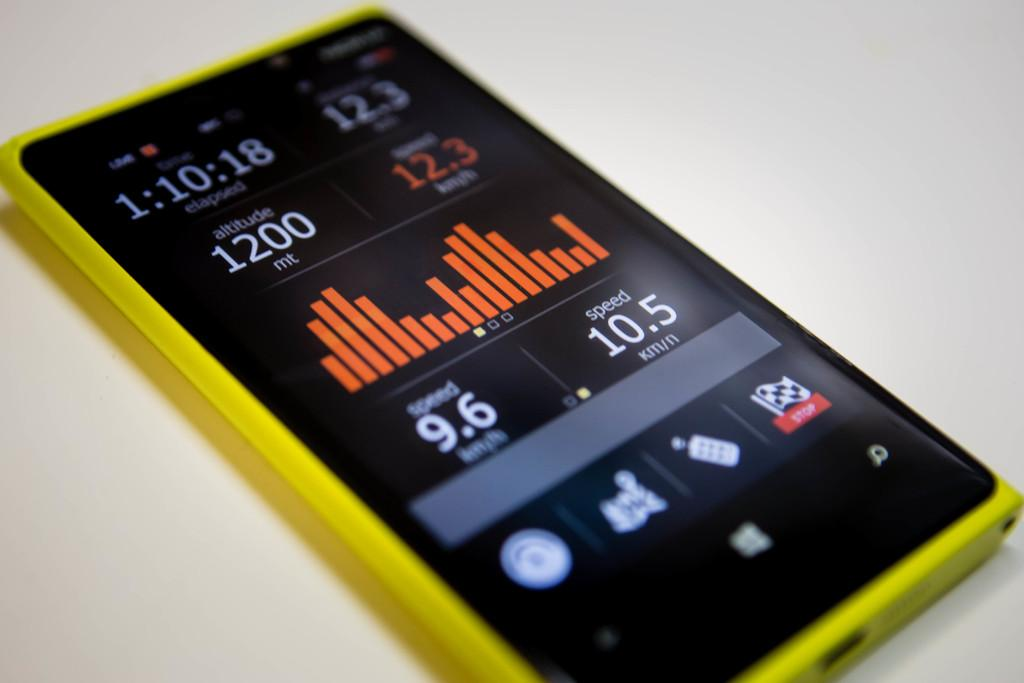<image>
Offer a succinct explanation of the picture presented. The app portrays the altitude level as "1200 mt" on the phone screen. 